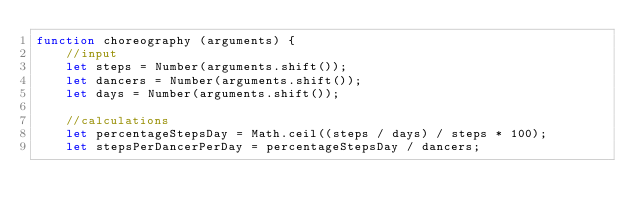<code> <loc_0><loc_0><loc_500><loc_500><_JavaScript_>function choreography (arguments) {
    //input
    let steps = Number(arguments.shift());
    let dancers = Number(arguments.shift());
    let days = Number(arguments.shift());
    
    //calculations
    let percentageStepsDay = Math.ceil((steps / days) / steps * 100);
    let stepsPerDancerPerDay = percentageStepsDay / dancers;
</code> 